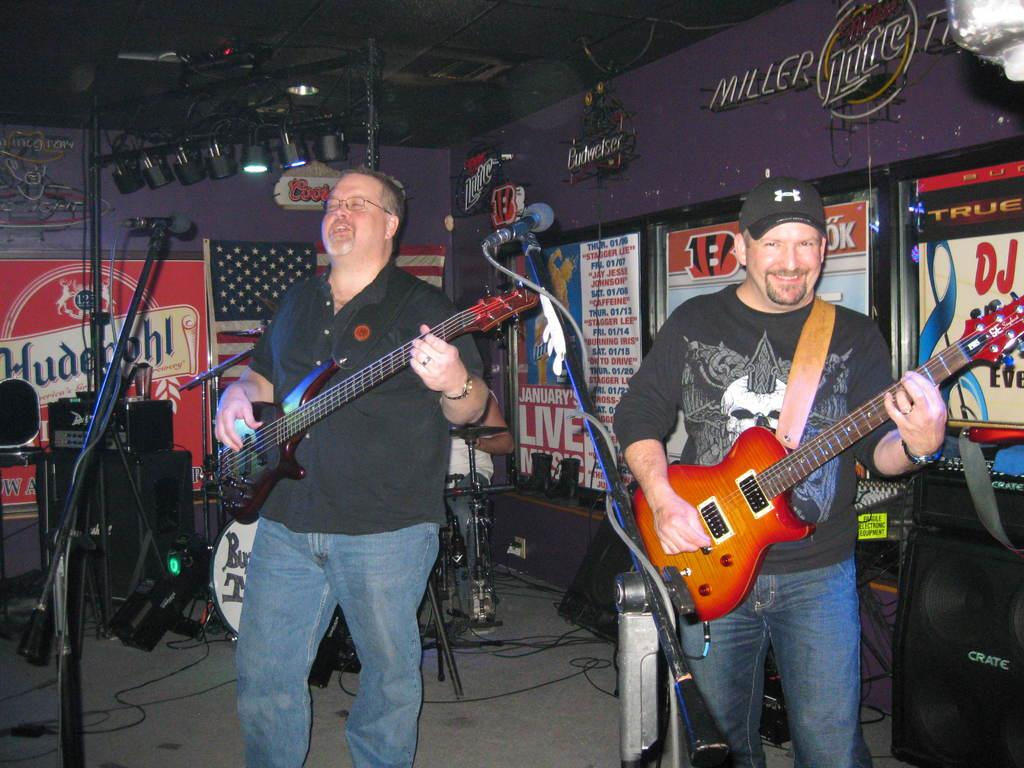How many people are in the image? There are two men in the image. What are the men doing in the image? The men are playing guitar. What object is present for amplifying sound in the image? There is a microphone in the image. What can be seen providing illumination in the image? There is a light in the image. What type of decoration is on the wall in the image? There are posters on the wall in the image. What type of writer is present in the image? There is no writer present in the image; it features two men playing guitar. What type of band is performing in the image? The image does not show a band performing; it only shows two men playing guitar. 